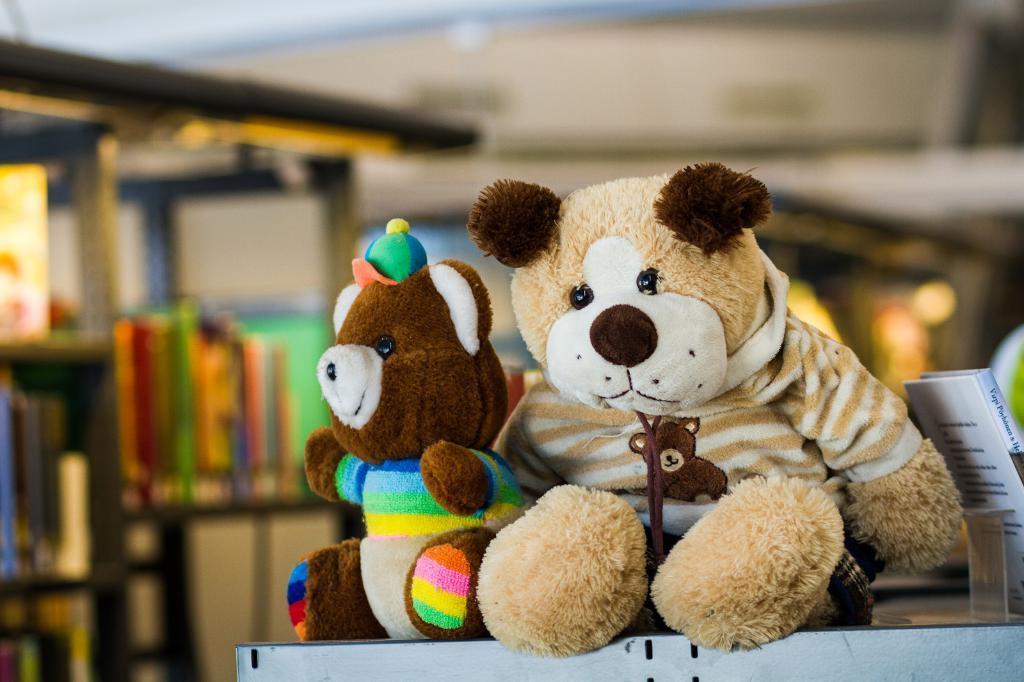Describe this image in one or two sentences. In this picture there are teddy bears in the center of the image and there is a rack on the left side of the image. 